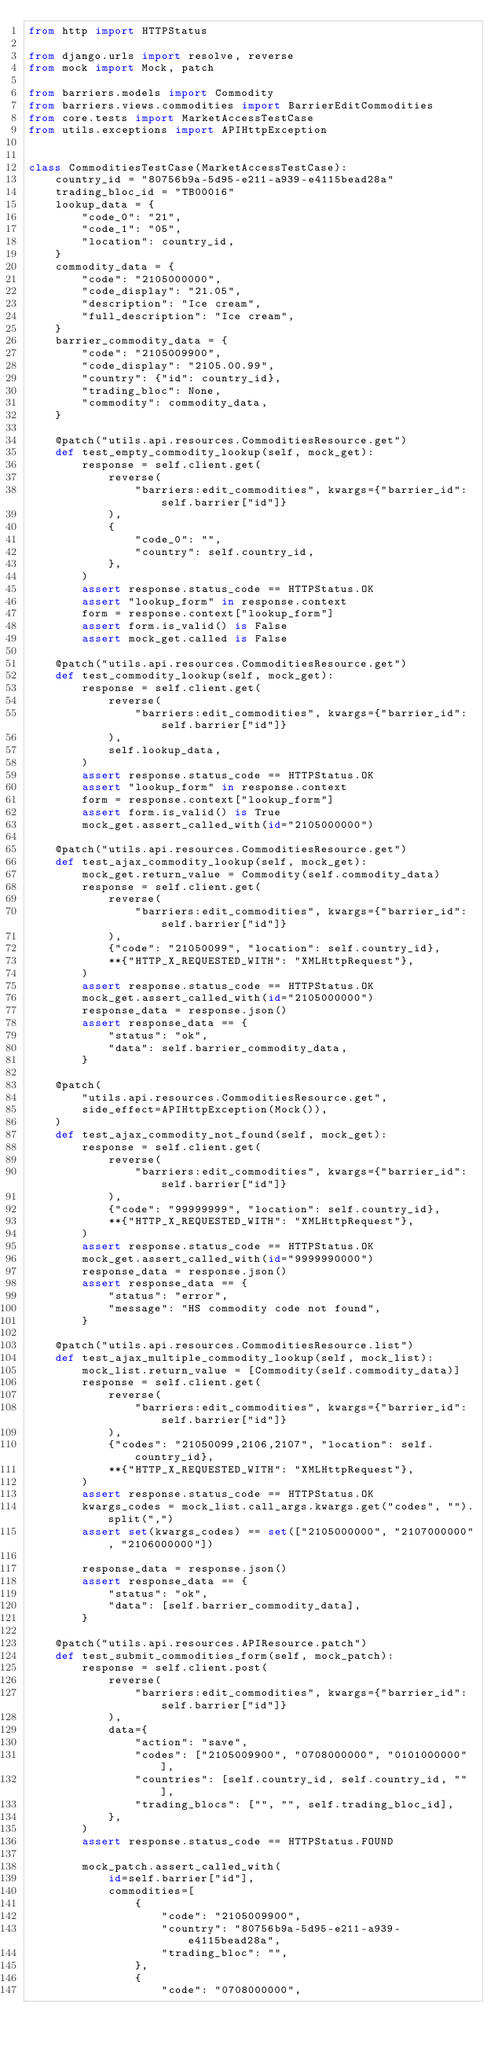Convert code to text. <code><loc_0><loc_0><loc_500><loc_500><_Python_>from http import HTTPStatus

from django.urls import resolve, reverse
from mock import Mock, patch

from barriers.models import Commodity
from barriers.views.commodities import BarrierEditCommodities
from core.tests import MarketAccessTestCase
from utils.exceptions import APIHttpException


class CommoditiesTestCase(MarketAccessTestCase):
    country_id = "80756b9a-5d95-e211-a939-e4115bead28a"
    trading_bloc_id = "TB00016"
    lookup_data = {
        "code_0": "21",
        "code_1": "05",
        "location": country_id,
    }
    commodity_data = {
        "code": "2105000000",
        "code_display": "21.05",
        "description": "Ice cream",
        "full_description": "Ice cream",
    }
    barrier_commodity_data = {
        "code": "2105009900",
        "code_display": "2105.00.99",
        "country": {"id": country_id},
        "trading_bloc": None,
        "commodity": commodity_data,
    }

    @patch("utils.api.resources.CommoditiesResource.get")
    def test_empty_commodity_lookup(self, mock_get):
        response = self.client.get(
            reverse(
                "barriers:edit_commodities", kwargs={"barrier_id": self.barrier["id"]}
            ),
            {
                "code_0": "",
                "country": self.country_id,
            },
        )
        assert response.status_code == HTTPStatus.OK
        assert "lookup_form" in response.context
        form = response.context["lookup_form"]
        assert form.is_valid() is False
        assert mock_get.called is False

    @patch("utils.api.resources.CommoditiesResource.get")
    def test_commodity_lookup(self, mock_get):
        response = self.client.get(
            reverse(
                "barriers:edit_commodities", kwargs={"barrier_id": self.barrier["id"]}
            ),
            self.lookup_data,
        )
        assert response.status_code == HTTPStatus.OK
        assert "lookup_form" in response.context
        form = response.context["lookup_form"]
        assert form.is_valid() is True
        mock_get.assert_called_with(id="2105000000")

    @patch("utils.api.resources.CommoditiesResource.get")
    def test_ajax_commodity_lookup(self, mock_get):
        mock_get.return_value = Commodity(self.commodity_data)
        response = self.client.get(
            reverse(
                "barriers:edit_commodities", kwargs={"barrier_id": self.barrier["id"]}
            ),
            {"code": "21050099", "location": self.country_id},
            **{"HTTP_X_REQUESTED_WITH": "XMLHttpRequest"},
        )
        assert response.status_code == HTTPStatus.OK
        mock_get.assert_called_with(id="2105000000")
        response_data = response.json()
        assert response_data == {
            "status": "ok",
            "data": self.barrier_commodity_data,
        }

    @patch(
        "utils.api.resources.CommoditiesResource.get",
        side_effect=APIHttpException(Mock()),
    )
    def test_ajax_commodity_not_found(self, mock_get):
        response = self.client.get(
            reverse(
                "barriers:edit_commodities", kwargs={"barrier_id": self.barrier["id"]}
            ),
            {"code": "99999999", "location": self.country_id},
            **{"HTTP_X_REQUESTED_WITH": "XMLHttpRequest"},
        )
        assert response.status_code == HTTPStatus.OK
        mock_get.assert_called_with(id="9999990000")
        response_data = response.json()
        assert response_data == {
            "status": "error",
            "message": "HS commodity code not found",
        }

    @patch("utils.api.resources.CommoditiesResource.list")
    def test_ajax_multiple_commodity_lookup(self, mock_list):
        mock_list.return_value = [Commodity(self.commodity_data)]
        response = self.client.get(
            reverse(
                "barriers:edit_commodities", kwargs={"barrier_id": self.barrier["id"]}
            ),
            {"codes": "21050099,2106,2107", "location": self.country_id},
            **{"HTTP_X_REQUESTED_WITH": "XMLHttpRequest"},
        )
        assert response.status_code == HTTPStatus.OK
        kwargs_codes = mock_list.call_args.kwargs.get("codes", "").split(",")
        assert set(kwargs_codes) == set(["2105000000", "2107000000", "2106000000"])

        response_data = response.json()
        assert response_data == {
            "status": "ok",
            "data": [self.barrier_commodity_data],
        }

    @patch("utils.api.resources.APIResource.patch")
    def test_submit_commodities_form(self, mock_patch):
        response = self.client.post(
            reverse(
                "barriers:edit_commodities", kwargs={"barrier_id": self.barrier["id"]}
            ),
            data={
                "action": "save",
                "codes": ["2105009900", "0708000000", "0101000000"],
                "countries": [self.country_id, self.country_id, ""],
                "trading_blocs": ["", "", self.trading_bloc_id],
            },
        )
        assert response.status_code == HTTPStatus.FOUND

        mock_patch.assert_called_with(
            id=self.barrier["id"],
            commodities=[
                {
                    "code": "2105009900",
                    "country": "80756b9a-5d95-e211-a939-e4115bead28a",
                    "trading_bloc": "",
                },
                {
                    "code": "0708000000",</code> 